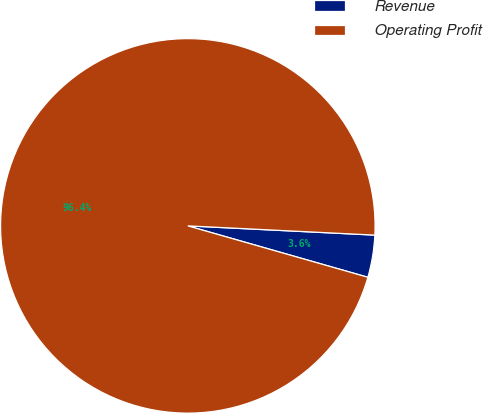Convert chart to OTSL. <chart><loc_0><loc_0><loc_500><loc_500><pie_chart><fcel>Revenue<fcel>Operating Profit<nl><fcel>3.64%<fcel>96.36%<nl></chart> 